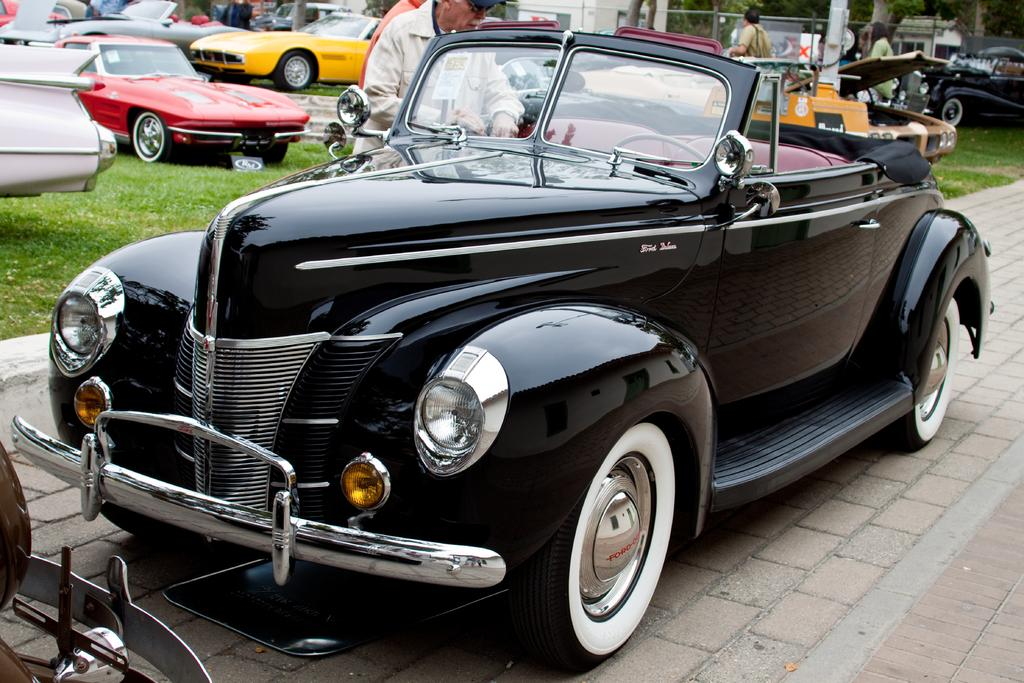What color is the car on the path in the image? The car on the path is black. What can be seen in the background of the image? In the background, there are cars on the grass, a house, a wire fence, plants, and a group of people. Can you describe the location of the house in the image? The house is in the background of the image. What type of vegetation is present in the background? Plants are present in the background. How many mountains can be seen in the image? There are no mountains visible in the image. What type of flame is being used by the group of people in the image? There is no flame present in the image; it features a black car on the path and various background elements. 